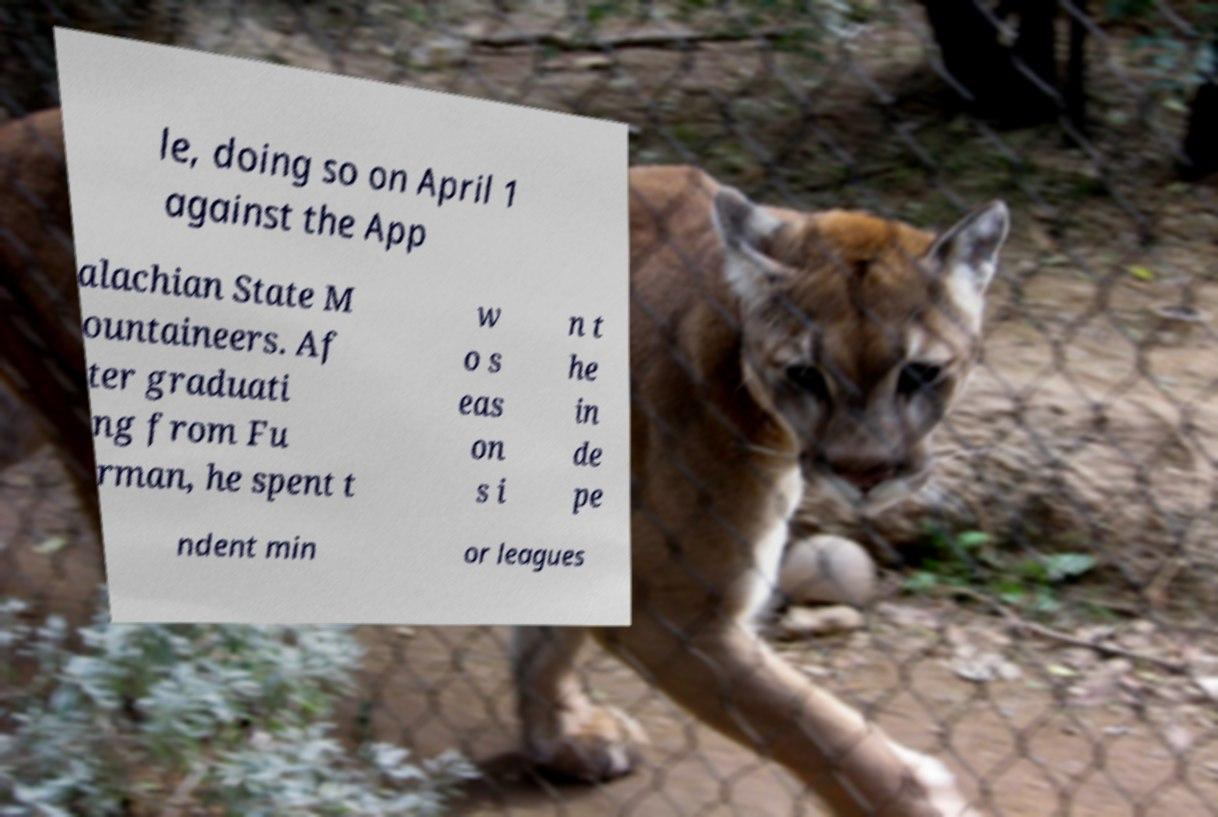Can you accurately transcribe the text from the provided image for me? le, doing so on April 1 against the App alachian State M ountaineers. Af ter graduati ng from Fu rman, he spent t w o s eas on s i n t he in de pe ndent min or leagues 